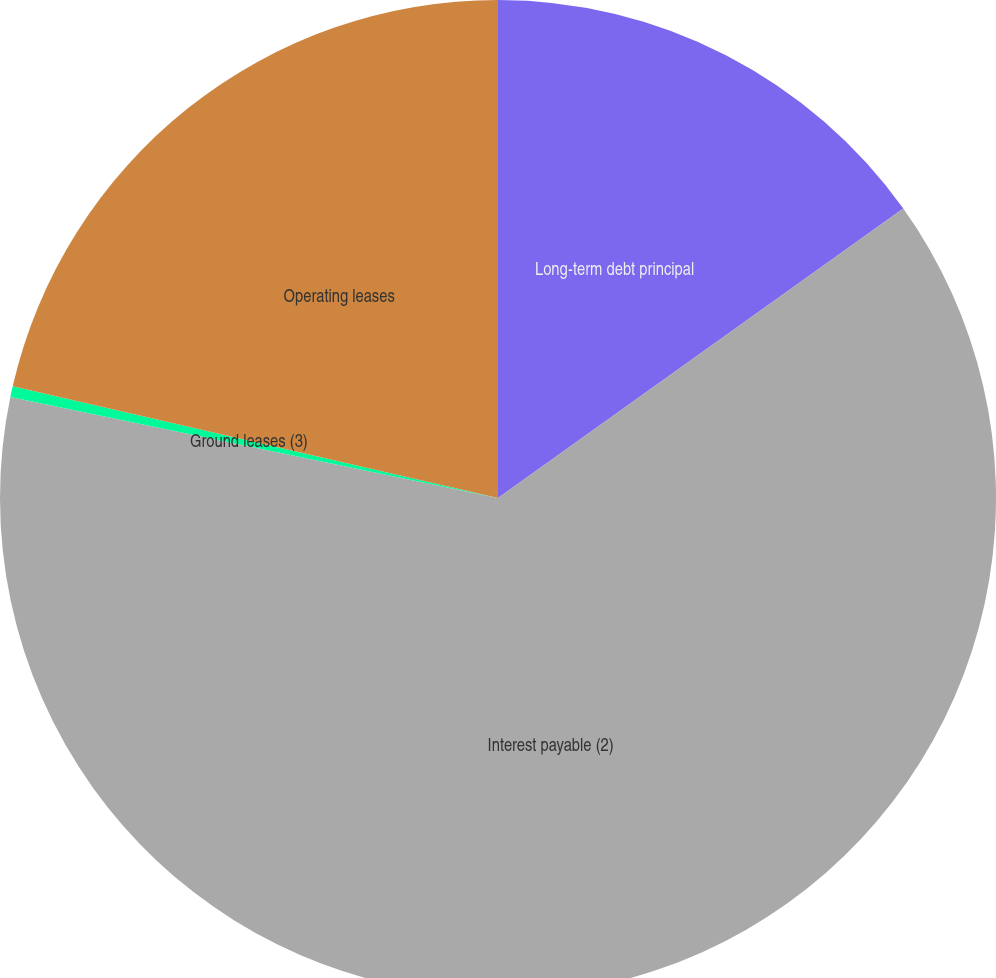Convert chart to OTSL. <chart><loc_0><loc_0><loc_500><loc_500><pie_chart><fcel>Long-term debt principal<fcel>Interest payable (2)<fcel>Ground leases (3)<fcel>Operating leases<nl><fcel>15.13%<fcel>63.12%<fcel>0.35%<fcel>21.4%<nl></chart> 